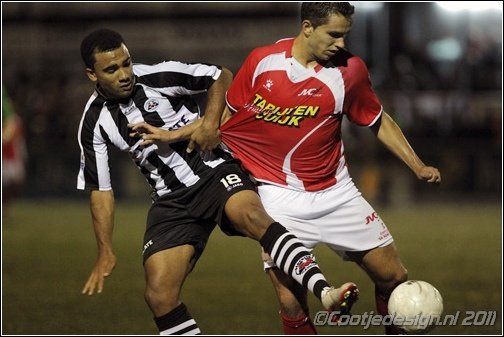Describe the objects in this image and their specific colors. I can see people in black, lightgray, maroon, and olive tones, people in black, lightgray, brown, and maroon tones, and sports ball in black, beige, and tan tones in this image. 